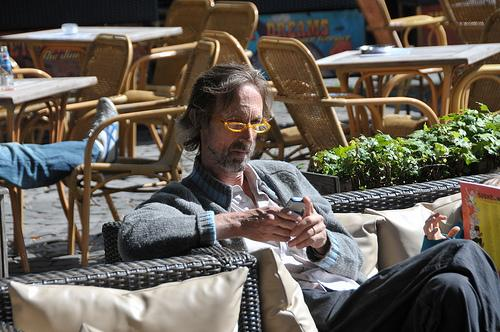What is the man wearing?

Choices:
A) crown
B) glasses
C) backpack
D) hat glasses 